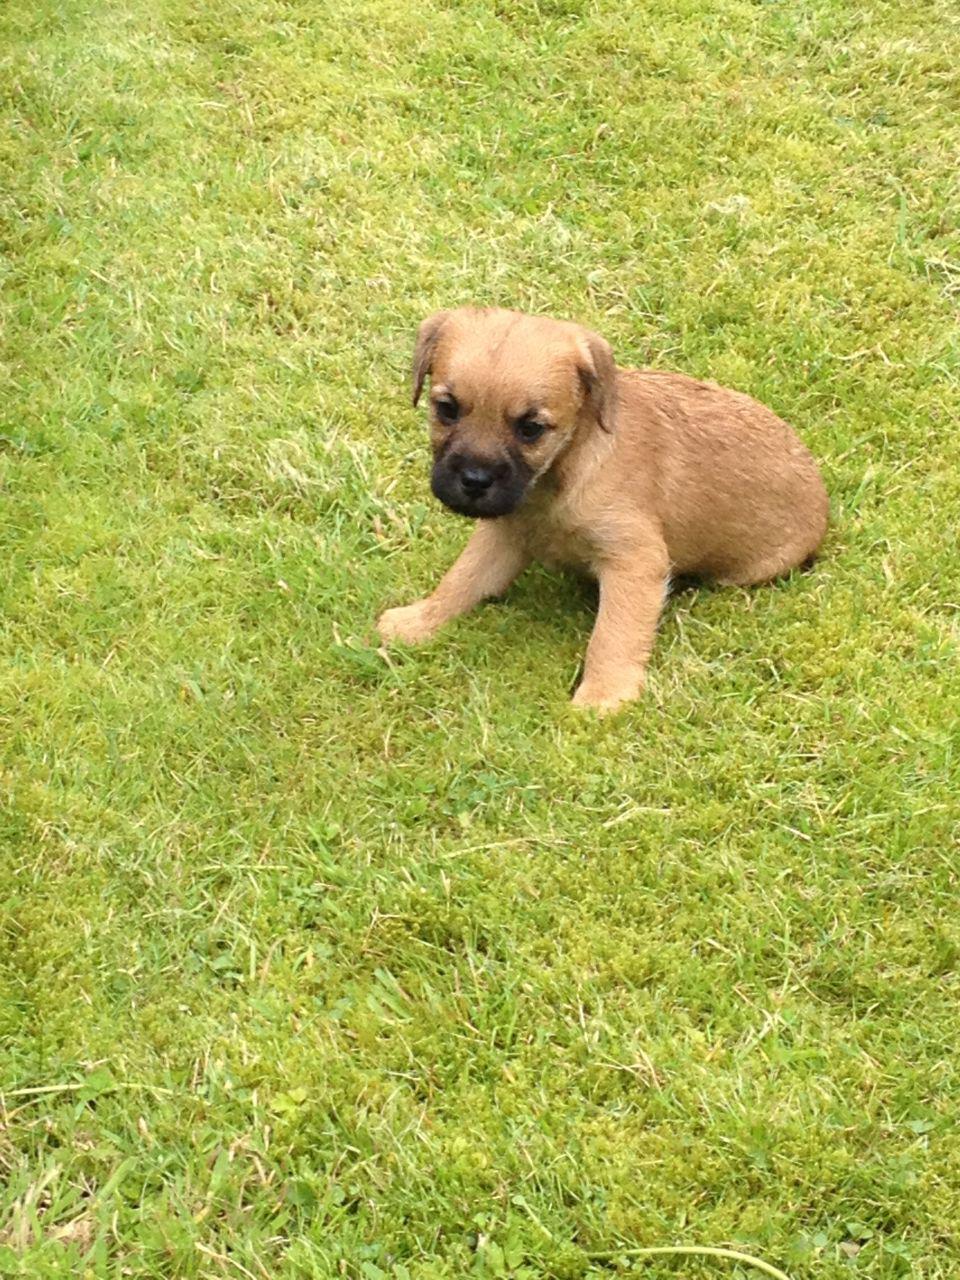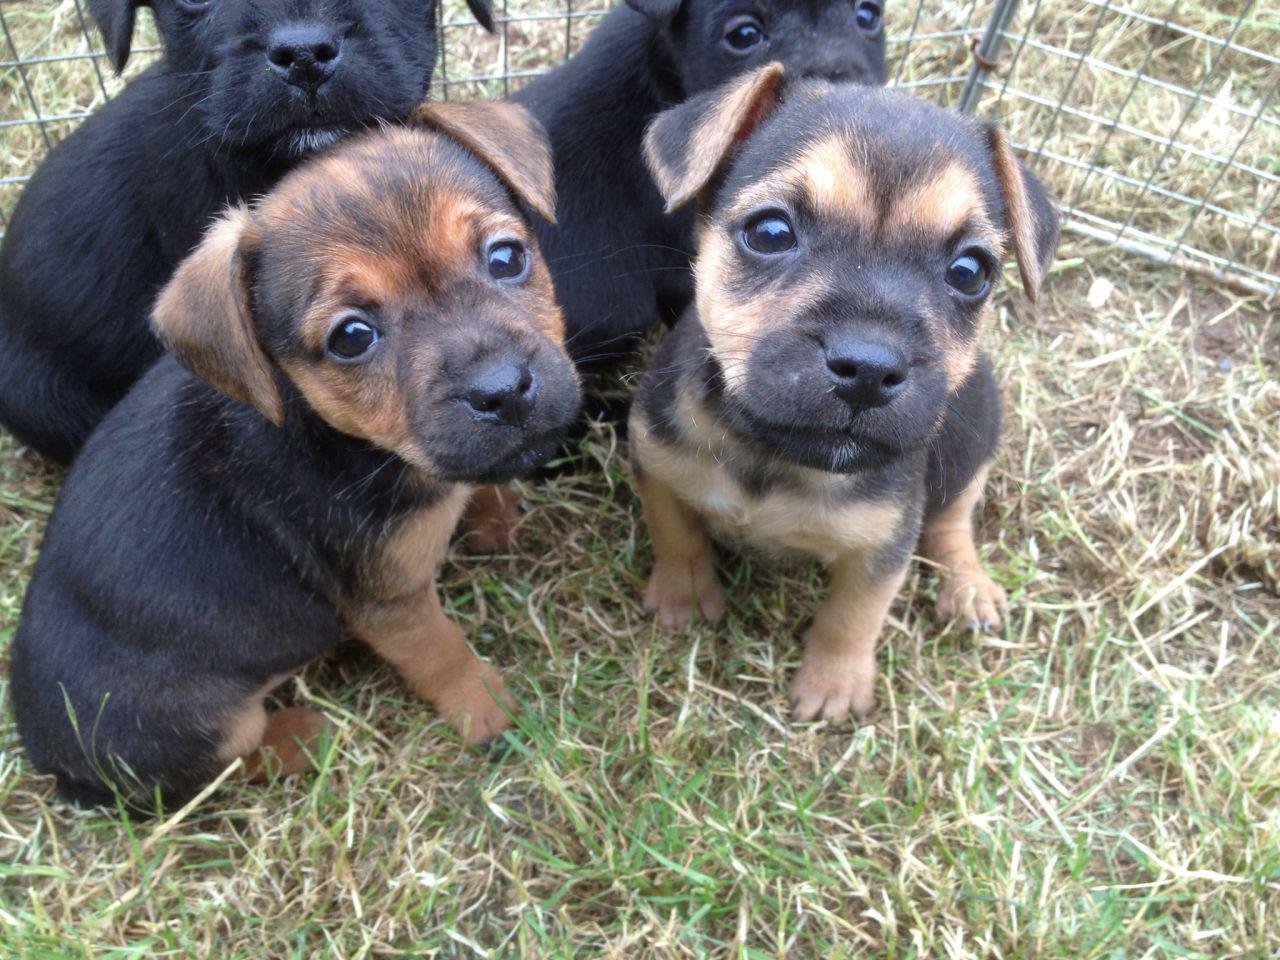The first image is the image on the left, the second image is the image on the right. Evaluate the accuracy of this statement regarding the images: "Left image shows a dog wearing a collar.". Is it true? Answer yes or no. No. The first image is the image on the left, the second image is the image on the right. For the images displayed, is the sentence "One dog is wearing a collar and has its mouth closed." factually correct? Answer yes or no. No. 